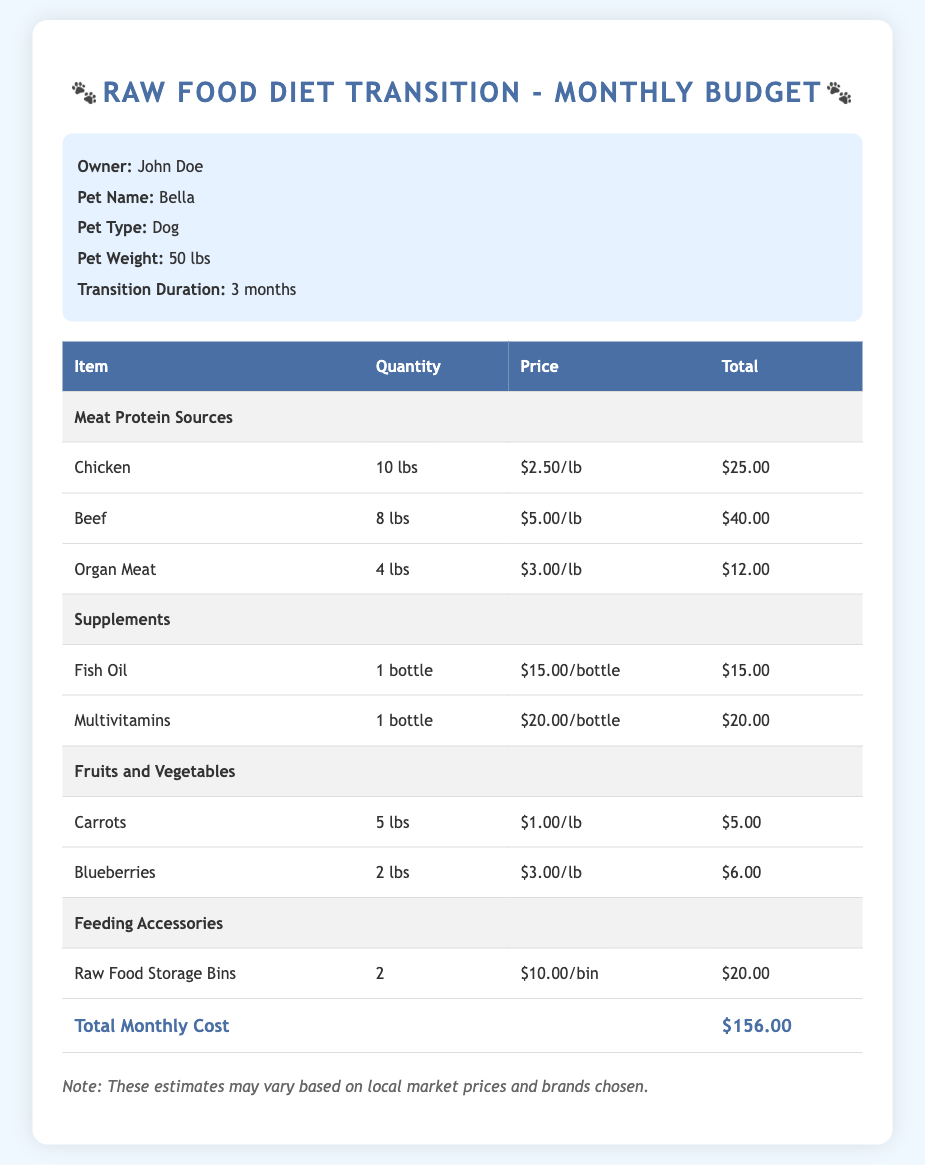what is the pet name? The pet name listed in the document is Bella.
Answer: Bella how much does chicken cost per pound? The document states that chicken costs $2.50 per pound.
Answer: $2.50/lb what is the total monthly cost for the raw food diet? The total monthly cost is clearly stated in the document, which is $156.00.
Answer: $156.00 how many lbs of beef are included in the budget? The document specifies that there are 8 lbs of beef included in the budget.
Answer: 8 lbs what is the quantity of multivitamins purchased? The document indicates that 1 bottle of multivitamins is purchased.
Answer: 1 bottle how many types of meat protein sources are listed? The document lists three types of meat protein sources: Chicken, Beef, and Organ Meat.
Answer: 3 types what is the discount application note? The document does not provide a specific discount note; however, it mentions that prices may vary based on local market prices.
Answer: Prices may vary how much do the feeding accessories total? The feeding accessories, which include raw food storage bins, add up to $20.00 in total.
Answer: $20.00 how many lbs of carrots are budgeted? The budgeted quantity for carrots is 5 lbs, as stated in the document.
Answer: 5 lbs how many months will the transition last? The document states that the transition duration is 3 months.
Answer: 3 months 